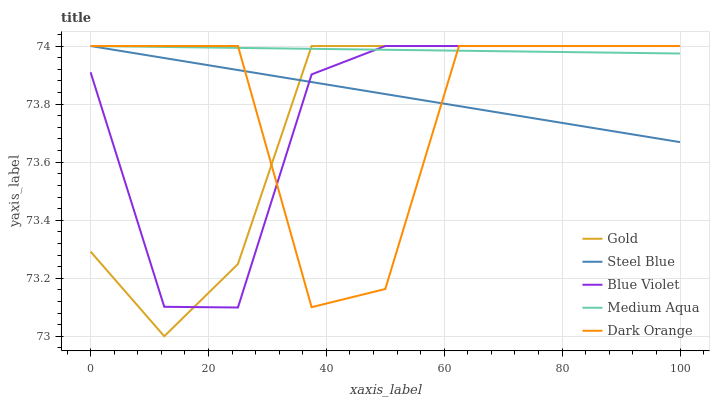Does Gold have the minimum area under the curve?
Answer yes or no. Yes. Does Medium Aqua have the maximum area under the curve?
Answer yes or no. Yes. Does Dark Orange have the minimum area under the curve?
Answer yes or no. No. Does Dark Orange have the maximum area under the curve?
Answer yes or no. No. Is Steel Blue the smoothest?
Answer yes or no. Yes. Is Dark Orange the roughest?
Answer yes or no. Yes. Is Medium Aqua the smoothest?
Answer yes or no. No. Is Medium Aqua the roughest?
Answer yes or no. No. Does Gold have the lowest value?
Answer yes or no. Yes. Does Dark Orange have the lowest value?
Answer yes or no. No. Does Gold have the highest value?
Answer yes or no. Yes. Does Steel Blue intersect Gold?
Answer yes or no. Yes. Is Steel Blue less than Gold?
Answer yes or no. No. Is Steel Blue greater than Gold?
Answer yes or no. No. 